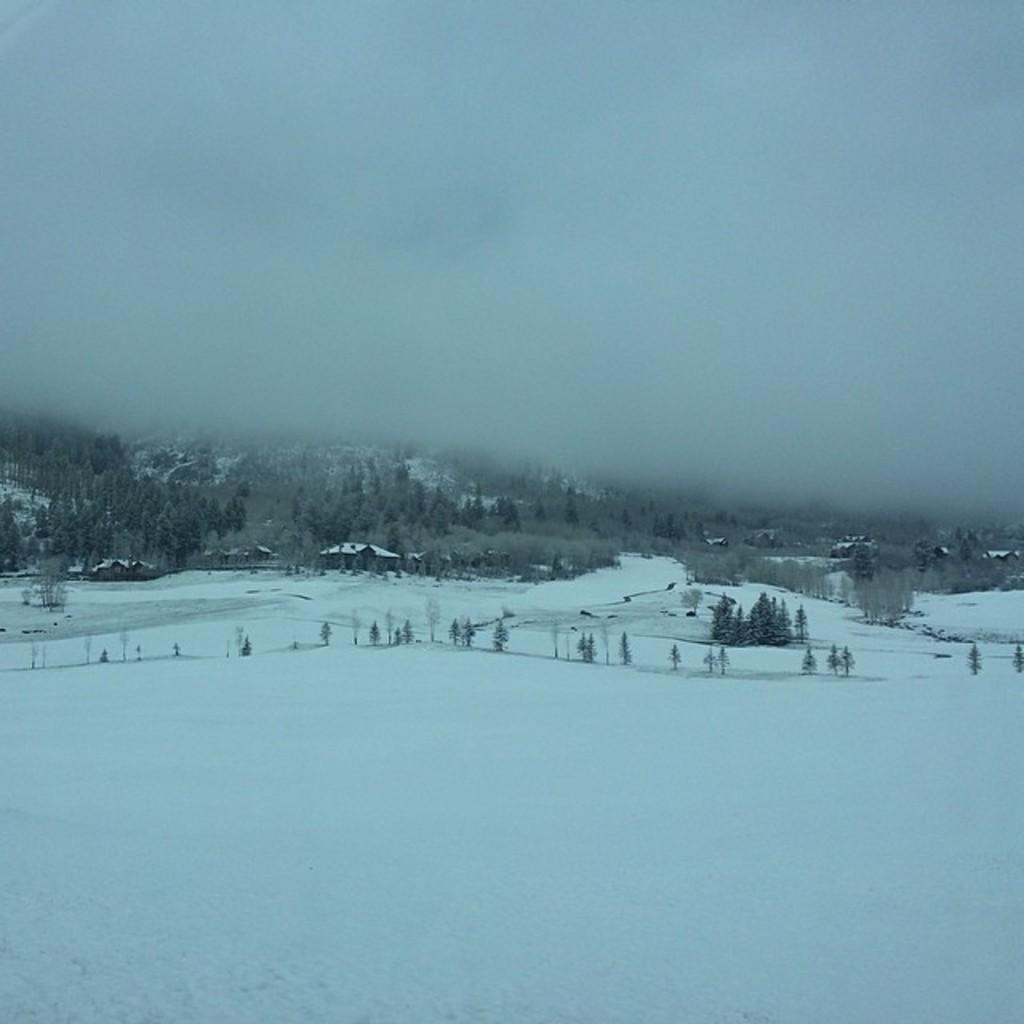Could you give a brief overview of what you see in this image? In this image I can see the snow, few trees and few buildings. In the background I can see the fog. 